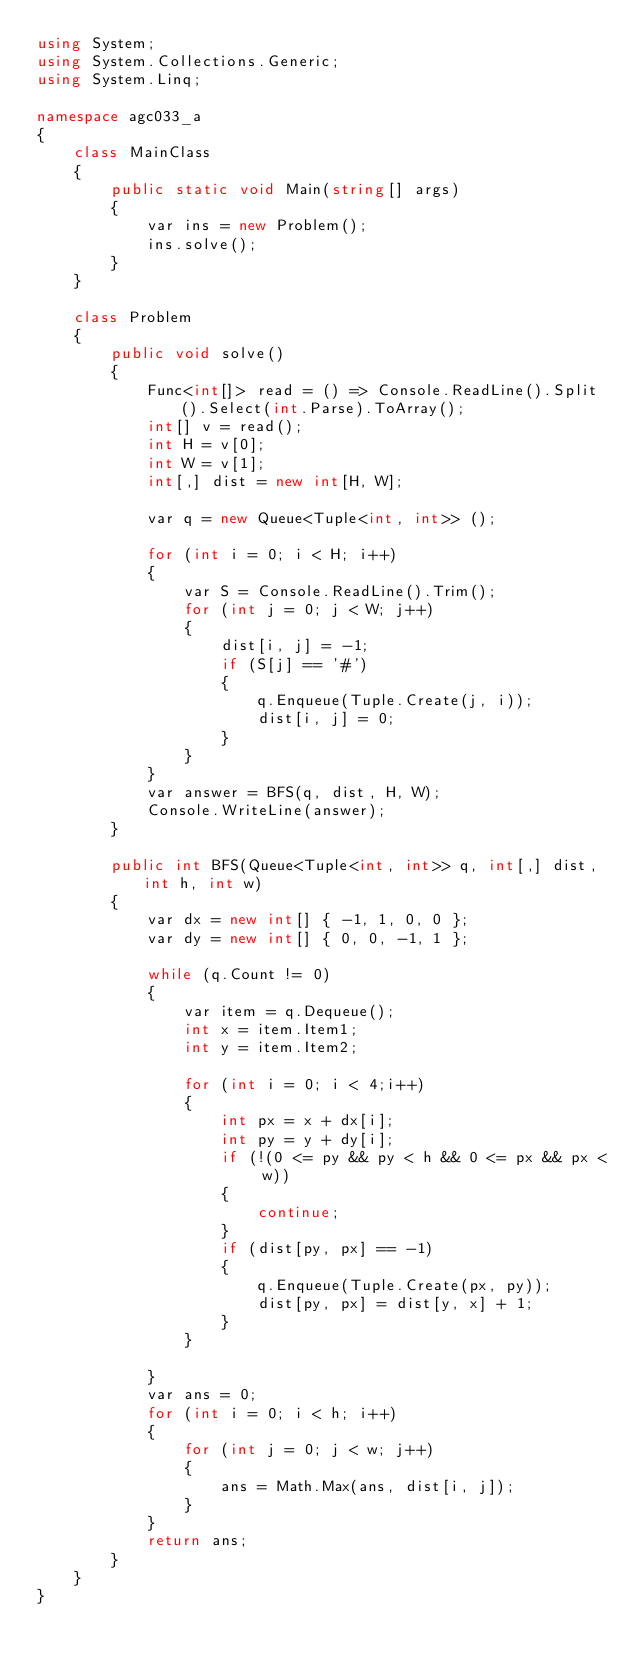Convert code to text. <code><loc_0><loc_0><loc_500><loc_500><_C#_>using System;
using System.Collections.Generic;
using System.Linq;

namespace agc033_a
{
    class MainClass
    {
        public static void Main(string[] args)
        {
            var ins = new Problem();
            ins.solve();
        }
    }

    class Problem
    {
        public void solve()
        {
            Func<int[]> read = () => Console.ReadLine().Split().Select(int.Parse).ToArray();
            int[] v = read();
            int H = v[0];
            int W = v[1];
            int[,] dist = new int[H, W];

            var q = new Queue<Tuple<int, int>> ();

            for (int i = 0; i < H; i++)
            {
                var S = Console.ReadLine().Trim();
                for (int j = 0; j < W; j++)
                {
                    dist[i, j] = -1;
                    if (S[j] == '#')
                    {
                        q.Enqueue(Tuple.Create(j, i));
                        dist[i, j] = 0;
                    }
                }
            }
            var answer = BFS(q, dist, H, W);
            Console.WriteLine(answer);
        }

        public int BFS(Queue<Tuple<int, int>> q, int[,] dist, int h, int w)
        {
            var dx = new int[] { -1, 1, 0, 0 };
            var dy = new int[] { 0, 0, -1, 1 };

            while (q.Count != 0)
            {
                var item = q.Dequeue();
                int x = item.Item1;
                int y = item.Item2;

                for (int i = 0; i < 4;i++)
                {
                    int px = x + dx[i];
                    int py = y + dy[i];
                    if (!(0 <= py && py < h && 0 <= px && px < w))
                    {
                        continue;
                    }
                    if (dist[py, px] == -1)
                    {
                        q.Enqueue(Tuple.Create(px, py));
                        dist[py, px] = dist[y, x] + 1;
                    }
                }

            }
            var ans = 0;
            for (int i = 0; i < h; i++)
            {
                for (int j = 0; j < w; j++)
                {
                    ans = Math.Max(ans, dist[i, j]);
                }
            }
            return ans;
        }
    }
}
</code> 